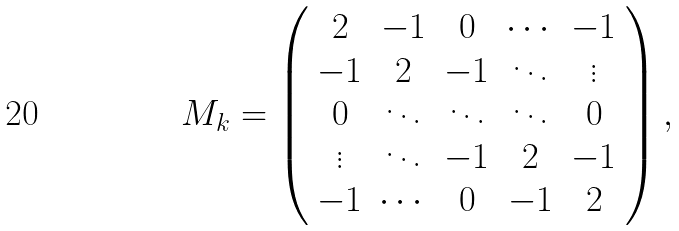Convert formula to latex. <formula><loc_0><loc_0><loc_500><loc_500>M _ { k } = \left ( \begin{array} { c c c c c c } 2 & - 1 & 0 & \cdots & - 1 \\ - 1 & 2 & - 1 & \ddots & \vdots \\ 0 & \ddots & \ddots & \ddots & 0 \\ \vdots & \ddots & - 1 & 2 & - 1 \\ - 1 & \cdots & 0 & - 1 & 2 \end{array} \right ) ,</formula> 